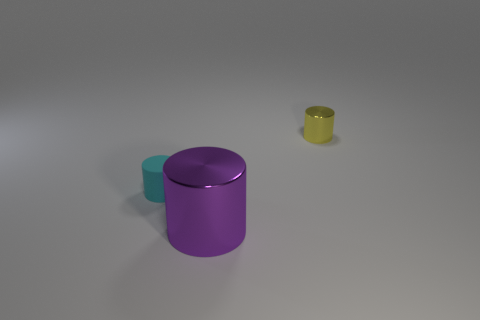What is the material of the tiny cyan object that is the same shape as the small yellow metallic object?
Provide a succinct answer. Rubber. How many brown cylinders have the same size as the yellow object?
Ensure brevity in your answer.  0. Do the yellow metal cylinder and the cyan thing have the same size?
Give a very brief answer. Yes. There is a cylinder that is on the right side of the cyan thing and behind the purple metallic cylinder; what size is it?
Ensure brevity in your answer.  Small. Are there more things that are behind the small cyan cylinder than purple cylinders that are in front of the big metallic cylinder?
Your answer should be very brief. Yes. What color is the tiny metallic object that is the same shape as the big metal thing?
Offer a very short reply. Yellow. Does the metallic thing that is on the right side of the big purple metallic cylinder have the same color as the large object?
Ensure brevity in your answer.  No. What number of big shiny cubes are there?
Your answer should be compact. 0. Is the cyan cylinder that is in front of the yellow thing made of the same material as the large cylinder?
Offer a very short reply. No. Is there anything else that has the same material as the purple cylinder?
Provide a short and direct response. Yes. 